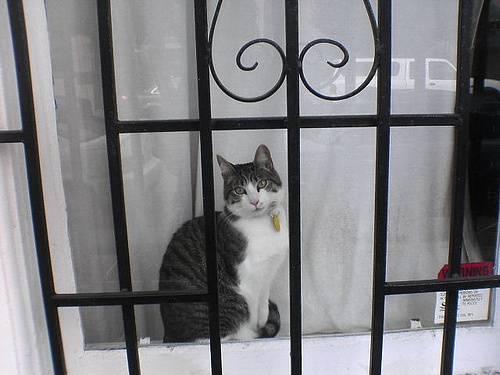Describe the objects in this image and their specific colors. I can see cat in darkgray, black, gray, and lightgray tones and car in darkgray and gray tones in this image. 